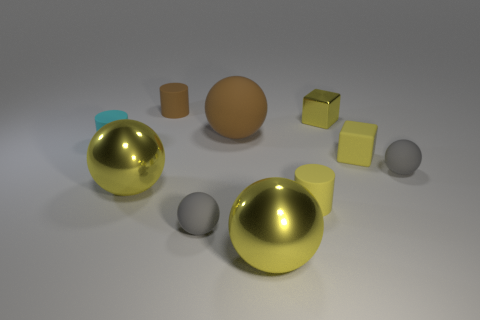There is a big thing that is the same material as the tiny cyan cylinder; what is its shape?
Make the answer very short. Sphere. There is a block on the left side of the rubber block; does it have the same color as the small block that is in front of the tiny shiny cube?
Ensure brevity in your answer.  Yes. Is the material of the yellow object that is behind the big brown object the same as the small brown cylinder?
Your answer should be compact. No. Is the number of large balls behind the cyan cylinder less than the number of small balls?
Your response must be concise. Yes. There is a yellow shiny object behind the small cyan rubber thing; what is its shape?
Offer a very short reply. Cube. There is a brown object that is the same size as the rubber block; what shape is it?
Offer a terse response. Cylinder. Are there any tiny matte things that have the same shape as the large rubber thing?
Provide a short and direct response. Yes. Do the large object that is right of the big matte object and the small gray matte object that is left of the small yellow matte cylinder have the same shape?
Offer a terse response. Yes. There is another cube that is the same size as the rubber cube; what is its material?
Your answer should be compact. Metal. What number of other objects are there of the same material as the small yellow cylinder?
Make the answer very short. 6. 